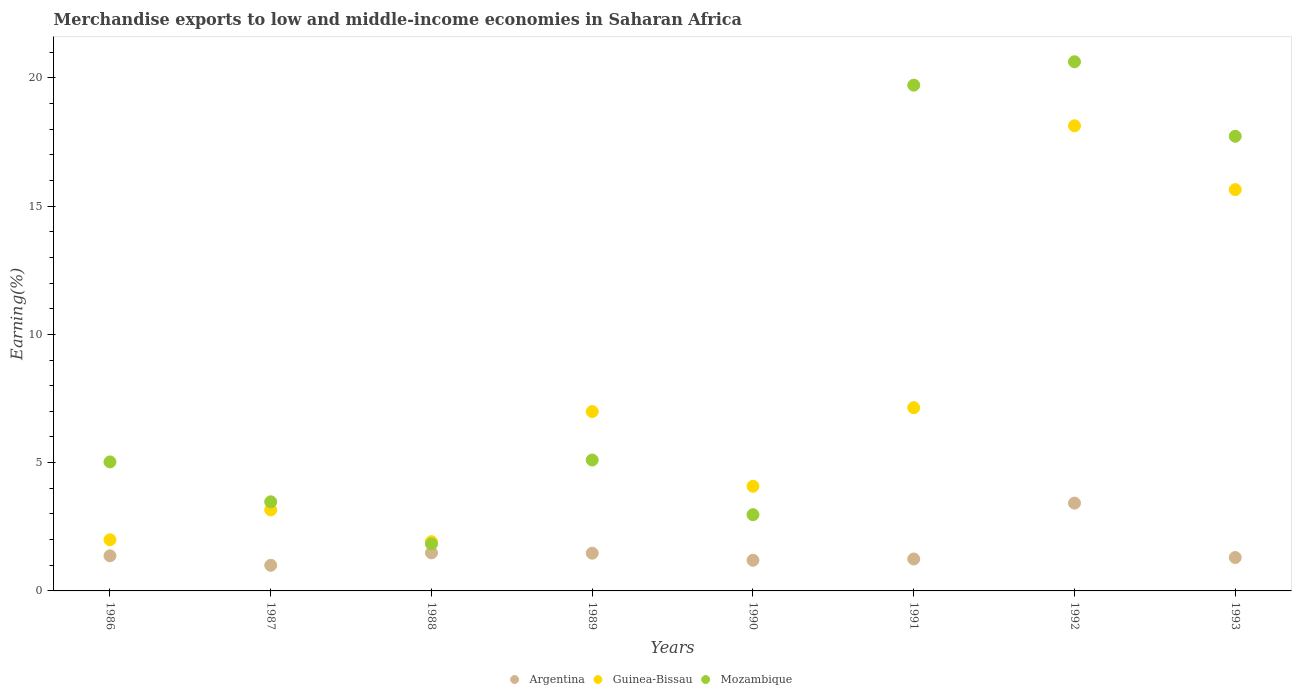What is the percentage of amount earned from merchandise exports in Mozambique in 1986?
Your answer should be very brief. 5.03. Across all years, what is the maximum percentage of amount earned from merchandise exports in Guinea-Bissau?
Offer a terse response. 18.13. Across all years, what is the minimum percentage of amount earned from merchandise exports in Argentina?
Keep it short and to the point. 1. In which year was the percentage of amount earned from merchandise exports in Guinea-Bissau minimum?
Make the answer very short. 1988. What is the total percentage of amount earned from merchandise exports in Guinea-Bissau in the graph?
Give a very brief answer. 59.05. What is the difference between the percentage of amount earned from merchandise exports in Mozambique in 1987 and that in 1992?
Your answer should be compact. -17.15. What is the difference between the percentage of amount earned from merchandise exports in Mozambique in 1993 and the percentage of amount earned from merchandise exports in Argentina in 1988?
Your answer should be compact. 16.24. What is the average percentage of amount earned from merchandise exports in Mozambique per year?
Give a very brief answer. 9.56. In the year 1992, what is the difference between the percentage of amount earned from merchandise exports in Mozambique and percentage of amount earned from merchandise exports in Argentina?
Your answer should be compact. 17.2. In how many years, is the percentage of amount earned from merchandise exports in Argentina greater than 7 %?
Your response must be concise. 0. What is the ratio of the percentage of amount earned from merchandise exports in Guinea-Bissau in 1986 to that in 1988?
Make the answer very short. 1.04. Is the difference between the percentage of amount earned from merchandise exports in Mozambique in 1990 and 1992 greater than the difference between the percentage of amount earned from merchandise exports in Argentina in 1990 and 1992?
Offer a terse response. No. What is the difference between the highest and the second highest percentage of amount earned from merchandise exports in Argentina?
Make the answer very short. 1.94. What is the difference between the highest and the lowest percentage of amount earned from merchandise exports in Guinea-Bissau?
Provide a succinct answer. 16.21. In how many years, is the percentage of amount earned from merchandise exports in Mozambique greater than the average percentage of amount earned from merchandise exports in Mozambique taken over all years?
Your answer should be very brief. 3. Is the sum of the percentage of amount earned from merchandise exports in Guinea-Bissau in 1988 and 1990 greater than the maximum percentage of amount earned from merchandise exports in Argentina across all years?
Keep it short and to the point. Yes. Is the percentage of amount earned from merchandise exports in Argentina strictly greater than the percentage of amount earned from merchandise exports in Mozambique over the years?
Keep it short and to the point. No. What is the difference between two consecutive major ticks on the Y-axis?
Your answer should be compact. 5. Are the values on the major ticks of Y-axis written in scientific E-notation?
Keep it short and to the point. No. Does the graph contain any zero values?
Keep it short and to the point. No. Does the graph contain grids?
Provide a succinct answer. No. How many legend labels are there?
Offer a very short reply. 3. How are the legend labels stacked?
Your answer should be compact. Horizontal. What is the title of the graph?
Ensure brevity in your answer.  Merchandise exports to low and middle-income economies in Saharan Africa. Does "Qatar" appear as one of the legend labels in the graph?
Give a very brief answer. No. What is the label or title of the X-axis?
Provide a short and direct response. Years. What is the label or title of the Y-axis?
Give a very brief answer. Earning(%). What is the Earning(%) in Argentina in 1986?
Offer a very short reply. 1.37. What is the Earning(%) in Guinea-Bissau in 1986?
Offer a very short reply. 1.99. What is the Earning(%) of Mozambique in 1986?
Your response must be concise. 5.03. What is the Earning(%) of Argentina in 1987?
Provide a succinct answer. 1. What is the Earning(%) of Guinea-Bissau in 1987?
Make the answer very short. 3.16. What is the Earning(%) in Mozambique in 1987?
Your answer should be very brief. 3.47. What is the Earning(%) of Argentina in 1988?
Ensure brevity in your answer.  1.48. What is the Earning(%) of Guinea-Bissau in 1988?
Your answer should be very brief. 1.92. What is the Earning(%) of Mozambique in 1988?
Your answer should be very brief. 1.83. What is the Earning(%) in Argentina in 1989?
Keep it short and to the point. 1.47. What is the Earning(%) in Guinea-Bissau in 1989?
Offer a very short reply. 6.99. What is the Earning(%) of Mozambique in 1989?
Keep it short and to the point. 5.1. What is the Earning(%) in Argentina in 1990?
Give a very brief answer. 1.19. What is the Earning(%) in Guinea-Bissau in 1990?
Keep it short and to the point. 4.08. What is the Earning(%) in Mozambique in 1990?
Provide a short and direct response. 2.97. What is the Earning(%) of Argentina in 1991?
Provide a succinct answer. 1.24. What is the Earning(%) of Guinea-Bissau in 1991?
Provide a succinct answer. 7.14. What is the Earning(%) of Mozambique in 1991?
Make the answer very short. 19.71. What is the Earning(%) in Argentina in 1992?
Your response must be concise. 3.42. What is the Earning(%) in Guinea-Bissau in 1992?
Provide a short and direct response. 18.13. What is the Earning(%) in Mozambique in 1992?
Give a very brief answer. 20.63. What is the Earning(%) in Argentina in 1993?
Your response must be concise. 1.3. What is the Earning(%) of Guinea-Bissau in 1993?
Ensure brevity in your answer.  15.64. What is the Earning(%) of Mozambique in 1993?
Keep it short and to the point. 17.72. Across all years, what is the maximum Earning(%) of Argentina?
Your answer should be compact. 3.42. Across all years, what is the maximum Earning(%) of Guinea-Bissau?
Your answer should be very brief. 18.13. Across all years, what is the maximum Earning(%) of Mozambique?
Offer a terse response. 20.63. Across all years, what is the minimum Earning(%) in Argentina?
Offer a very short reply. 1. Across all years, what is the minimum Earning(%) in Guinea-Bissau?
Make the answer very short. 1.92. Across all years, what is the minimum Earning(%) in Mozambique?
Make the answer very short. 1.83. What is the total Earning(%) of Argentina in the graph?
Provide a short and direct response. 12.49. What is the total Earning(%) of Guinea-Bissau in the graph?
Offer a terse response. 59.05. What is the total Earning(%) of Mozambique in the graph?
Keep it short and to the point. 76.47. What is the difference between the Earning(%) of Argentina in 1986 and that in 1987?
Offer a very short reply. 0.37. What is the difference between the Earning(%) in Guinea-Bissau in 1986 and that in 1987?
Ensure brevity in your answer.  -1.16. What is the difference between the Earning(%) of Mozambique in 1986 and that in 1987?
Give a very brief answer. 1.55. What is the difference between the Earning(%) in Argentina in 1986 and that in 1988?
Your response must be concise. -0.11. What is the difference between the Earning(%) in Guinea-Bissau in 1986 and that in 1988?
Your answer should be very brief. 0.07. What is the difference between the Earning(%) of Mozambique in 1986 and that in 1988?
Your answer should be very brief. 3.2. What is the difference between the Earning(%) in Argentina in 1986 and that in 1989?
Make the answer very short. -0.1. What is the difference between the Earning(%) in Guinea-Bissau in 1986 and that in 1989?
Give a very brief answer. -5. What is the difference between the Earning(%) of Mozambique in 1986 and that in 1989?
Ensure brevity in your answer.  -0.07. What is the difference between the Earning(%) in Argentina in 1986 and that in 1990?
Provide a succinct answer. 0.17. What is the difference between the Earning(%) of Guinea-Bissau in 1986 and that in 1990?
Provide a succinct answer. -2.09. What is the difference between the Earning(%) in Mozambique in 1986 and that in 1990?
Make the answer very short. 2.06. What is the difference between the Earning(%) of Argentina in 1986 and that in 1991?
Give a very brief answer. 0.12. What is the difference between the Earning(%) of Guinea-Bissau in 1986 and that in 1991?
Provide a short and direct response. -5.15. What is the difference between the Earning(%) of Mozambique in 1986 and that in 1991?
Provide a short and direct response. -14.69. What is the difference between the Earning(%) in Argentina in 1986 and that in 1992?
Provide a succinct answer. -2.05. What is the difference between the Earning(%) of Guinea-Bissau in 1986 and that in 1992?
Your response must be concise. -16.14. What is the difference between the Earning(%) in Mozambique in 1986 and that in 1992?
Make the answer very short. -15.6. What is the difference between the Earning(%) in Argentina in 1986 and that in 1993?
Provide a short and direct response. 0.07. What is the difference between the Earning(%) of Guinea-Bissau in 1986 and that in 1993?
Give a very brief answer. -13.65. What is the difference between the Earning(%) in Mozambique in 1986 and that in 1993?
Provide a short and direct response. -12.69. What is the difference between the Earning(%) of Argentina in 1987 and that in 1988?
Give a very brief answer. -0.48. What is the difference between the Earning(%) of Guinea-Bissau in 1987 and that in 1988?
Offer a terse response. 1.24. What is the difference between the Earning(%) in Mozambique in 1987 and that in 1988?
Your response must be concise. 1.64. What is the difference between the Earning(%) of Argentina in 1987 and that in 1989?
Ensure brevity in your answer.  -0.47. What is the difference between the Earning(%) in Guinea-Bissau in 1987 and that in 1989?
Ensure brevity in your answer.  -3.83. What is the difference between the Earning(%) of Mozambique in 1987 and that in 1989?
Ensure brevity in your answer.  -1.63. What is the difference between the Earning(%) in Argentina in 1987 and that in 1990?
Your answer should be very brief. -0.2. What is the difference between the Earning(%) in Guinea-Bissau in 1987 and that in 1990?
Offer a very short reply. -0.92. What is the difference between the Earning(%) in Mozambique in 1987 and that in 1990?
Your response must be concise. 0.5. What is the difference between the Earning(%) in Argentina in 1987 and that in 1991?
Provide a succinct answer. -0.25. What is the difference between the Earning(%) in Guinea-Bissau in 1987 and that in 1991?
Offer a terse response. -3.99. What is the difference between the Earning(%) of Mozambique in 1987 and that in 1991?
Your answer should be compact. -16.24. What is the difference between the Earning(%) of Argentina in 1987 and that in 1992?
Give a very brief answer. -2.42. What is the difference between the Earning(%) in Guinea-Bissau in 1987 and that in 1992?
Ensure brevity in your answer.  -14.97. What is the difference between the Earning(%) of Mozambique in 1987 and that in 1992?
Offer a terse response. -17.15. What is the difference between the Earning(%) in Argentina in 1987 and that in 1993?
Provide a succinct answer. -0.3. What is the difference between the Earning(%) in Guinea-Bissau in 1987 and that in 1993?
Offer a very short reply. -12.48. What is the difference between the Earning(%) in Mozambique in 1987 and that in 1993?
Make the answer very short. -14.25. What is the difference between the Earning(%) in Argentina in 1988 and that in 1989?
Provide a short and direct response. 0.01. What is the difference between the Earning(%) of Guinea-Bissau in 1988 and that in 1989?
Keep it short and to the point. -5.07. What is the difference between the Earning(%) in Mozambique in 1988 and that in 1989?
Provide a short and direct response. -3.27. What is the difference between the Earning(%) in Argentina in 1988 and that in 1990?
Keep it short and to the point. 0.29. What is the difference between the Earning(%) in Guinea-Bissau in 1988 and that in 1990?
Your answer should be very brief. -2.16. What is the difference between the Earning(%) in Mozambique in 1988 and that in 1990?
Make the answer very short. -1.14. What is the difference between the Earning(%) of Argentina in 1988 and that in 1991?
Keep it short and to the point. 0.24. What is the difference between the Earning(%) of Guinea-Bissau in 1988 and that in 1991?
Provide a short and direct response. -5.22. What is the difference between the Earning(%) in Mozambique in 1988 and that in 1991?
Give a very brief answer. -17.88. What is the difference between the Earning(%) of Argentina in 1988 and that in 1992?
Offer a very short reply. -1.94. What is the difference between the Earning(%) in Guinea-Bissau in 1988 and that in 1992?
Provide a short and direct response. -16.21. What is the difference between the Earning(%) of Mozambique in 1988 and that in 1992?
Give a very brief answer. -18.79. What is the difference between the Earning(%) of Argentina in 1988 and that in 1993?
Give a very brief answer. 0.18. What is the difference between the Earning(%) of Guinea-Bissau in 1988 and that in 1993?
Keep it short and to the point. -13.72. What is the difference between the Earning(%) in Mozambique in 1988 and that in 1993?
Your response must be concise. -15.89. What is the difference between the Earning(%) in Argentina in 1989 and that in 1990?
Your answer should be compact. 0.28. What is the difference between the Earning(%) of Guinea-Bissau in 1989 and that in 1990?
Provide a short and direct response. 2.91. What is the difference between the Earning(%) in Mozambique in 1989 and that in 1990?
Make the answer very short. 2.13. What is the difference between the Earning(%) of Argentina in 1989 and that in 1991?
Provide a short and direct response. 0.23. What is the difference between the Earning(%) in Guinea-Bissau in 1989 and that in 1991?
Offer a terse response. -0.15. What is the difference between the Earning(%) in Mozambique in 1989 and that in 1991?
Give a very brief answer. -14.61. What is the difference between the Earning(%) in Argentina in 1989 and that in 1992?
Provide a succinct answer. -1.95. What is the difference between the Earning(%) of Guinea-Bissau in 1989 and that in 1992?
Provide a short and direct response. -11.14. What is the difference between the Earning(%) of Mozambique in 1989 and that in 1992?
Ensure brevity in your answer.  -15.52. What is the difference between the Earning(%) in Argentina in 1989 and that in 1993?
Your answer should be compact. 0.17. What is the difference between the Earning(%) in Guinea-Bissau in 1989 and that in 1993?
Provide a short and direct response. -8.65. What is the difference between the Earning(%) in Mozambique in 1989 and that in 1993?
Provide a short and direct response. -12.62. What is the difference between the Earning(%) of Argentina in 1990 and that in 1991?
Your response must be concise. -0.05. What is the difference between the Earning(%) in Guinea-Bissau in 1990 and that in 1991?
Make the answer very short. -3.06. What is the difference between the Earning(%) of Mozambique in 1990 and that in 1991?
Your answer should be compact. -16.74. What is the difference between the Earning(%) of Argentina in 1990 and that in 1992?
Provide a succinct answer. -2.23. What is the difference between the Earning(%) of Guinea-Bissau in 1990 and that in 1992?
Offer a terse response. -14.05. What is the difference between the Earning(%) of Mozambique in 1990 and that in 1992?
Your answer should be very brief. -17.65. What is the difference between the Earning(%) of Argentina in 1990 and that in 1993?
Give a very brief answer. -0.11. What is the difference between the Earning(%) in Guinea-Bissau in 1990 and that in 1993?
Your answer should be compact. -11.56. What is the difference between the Earning(%) in Mozambique in 1990 and that in 1993?
Provide a short and direct response. -14.75. What is the difference between the Earning(%) in Argentina in 1991 and that in 1992?
Keep it short and to the point. -2.18. What is the difference between the Earning(%) of Guinea-Bissau in 1991 and that in 1992?
Give a very brief answer. -10.99. What is the difference between the Earning(%) in Mozambique in 1991 and that in 1992?
Make the answer very short. -0.91. What is the difference between the Earning(%) of Argentina in 1991 and that in 1993?
Offer a very short reply. -0.06. What is the difference between the Earning(%) of Guinea-Bissau in 1991 and that in 1993?
Provide a succinct answer. -8.5. What is the difference between the Earning(%) in Mozambique in 1991 and that in 1993?
Make the answer very short. 1.99. What is the difference between the Earning(%) in Argentina in 1992 and that in 1993?
Offer a very short reply. 2.12. What is the difference between the Earning(%) in Guinea-Bissau in 1992 and that in 1993?
Your answer should be very brief. 2.49. What is the difference between the Earning(%) of Mozambique in 1992 and that in 1993?
Offer a terse response. 2.9. What is the difference between the Earning(%) in Argentina in 1986 and the Earning(%) in Guinea-Bissau in 1987?
Offer a terse response. -1.79. What is the difference between the Earning(%) of Argentina in 1986 and the Earning(%) of Mozambique in 1987?
Offer a terse response. -2.1. What is the difference between the Earning(%) of Guinea-Bissau in 1986 and the Earning(%) of Mozambique in 1987?
Provide a short and direct response. -1.48. What is the difference between the Earning(%) in Argentina in 1986 and the Earning(%) in Guinea-Bissau in 1988?
Keep it short and to the point. -0.55. What is the difference between the Earning(%) of Argentina in 1986 and the Earning(%) of Mozambique in 1988?
Your answer should be very brief. -0.46. What is the difference between the Earning(%) in Guinea-Bissau in 1986 and the Earning(%) in Mozambique in 1988?
Offer a terse response. 0.16. What is the difference between the Earning(%) in Argentina in 1986 and the Earning(%) in Guinea-Bissau in 1989?
Give a very brief answer. -5.62. What is the difference between the Earning(%) in Argentina in 1986 and the Earning(%) in Mozambique in 1989?
Your answer should be very brief. -3.73. What is the difference between the Earning(%) in Guinea-Bissau in 1986 and the Earning(%) in Mozambique in 1989?
Ensure brevity in your answer.  -3.11. What is the difference between the Earning(%) of Argentina in 1986 and the Earning(%) of Guinea-Bissau in 1990?
Offer a very short reply. -2.71. What is the difference between the Earning(%) of Argentina in 1986 and the Earning(%) of Mozambique in 1990?
Provide a succinct answer. -1.6. What is the difference between the Earning(%) of Guinea-Bissau in 1986 and the Earning(%) of Mozambique in 1990?
Offer a very short reply. -0.98. What is the difference between the Earning(%) in Argentina in 1986 and the Earning(%) in Guinea-Bissau in 1991?
Ensure brevity in your answer.  -5.77. What is the difference between the Earning(%) in Argentina in 1986 and the Earning(%) in Mozambique in 1991?
Offer a terse response. -18.34. What is the difference between the Earning(%) of Guinea-Bissau in 1986 and the Earning(%) of Mozambique in 1991?
Ensure brevity in your answer.  -17.72. What is the difference between the Earning(%) in Argentina in 1986 and the Earning(%) in Guinea-Bissau in 1992?
Provide a short and direct response. -16.76. What is the difference between the Earning(%) of Argentina in 1986 and the Earning(%) of Mozambique in 1992?
Provide a short and direct response. -19.26. What is the difference between the Earning(%) of Guinea-Bissau in 1986 and the Earning(%) of Mozambique in 1992?
Keep it short and to the point. -18.63. What is the difference between the Earning(%) of Argentina in 1986 and the Earning(%) of Guinea-Bissau in 1993?
Your answer should be very brief. -14.27. What is the difference between the Earning(%) of Argentina in 1986 and the Earning(%) of Mozambique in 1993?
Provide a succinct answer. -16.35. What is the difference between the Earning(%) of Guinea-Bissau in 1986 and the Earning(%) of Mozambique in 1993?
Your response must be concise. -15.73. What is the difference between the Earning(%) of Argentina in 1987 and the Earning(%) of Guinea-Bissau in 1988?
Provide a short and direct response. -0.92. What is the difference between the Earning(%) in Argentina in 1987 and the Earning(%) in Mozambique in 1988?
Your answer should be compact. -0.83. What is the difference between the Earning(%) in Guinea-Bissau in 1987 and the Earning(%) in Mozambique in 1988?
Make the answer very short. 1.33. What is the difference between the Earning(%) of Argentina in 1987 and the Earning(%) of Guinea-Bissau in 1989?
Provide a succinct answer. -5.99. What is the difference between the Earning(%) of Argentina in 1987 and the Earning(%) of Mozambique in 1989?
Provide a succinct answer. -4.1. What is the difference between the Earning(%) in Guinea-Bissau in 1987 and the Earning(%) in Mozambique in 1989?
Make the answer very short. -1.94. What is the difference between the Earning(%) in Argentina in 1987 and the Earning(%) in Guinea-Bissau in 1990?
Provide a succinct answer. -3.08. What is the difference between the Earning(%) in Argentina in 1987 and the Earning(%) in Mozambique in 1990?
Make the answer very short. -1.97. What is the difference between the Earning(%) of Guinea-Bissau in 1987 and the Earning(%) of Mozambique in 1990?
Provide a short and direct response. 0.19. What is the difference between the Earning(%) of Argentina in 1987 and the Earning(%) of Guinea-Bissau in 1991?
Your answer should be very brief. -6.14. What is the difference between the Earning(%) of Argentina in 1987 and the Earning(%) of Mozambique in 1991?
Give a very brief answer. -18.71. What is the difference between the Earning(%) of Guinea-Bissau in 1987 and the Earning(%) of Mozambique in 1991?
Make the answer very short. -16.56. What is the difference between the Earning(%) in Argentina in 1987 and the Earning(%) in Guinea-Bissau in 1992?
Make the answer very short. -17.13. What is the difference between the Earning(%) of Argentina in 1987 and the Earning(%) of Mozambique in 1992?
Your response must be concise. -19.63. What is the difference between the Earning(%) in Guinea-Bissau in 1987 and the Earning(%) in Mozambique in 1992?
Provide a short and direct response. -17.47. What is the difference between the Earning(%) in Argentina in 1987 and the Earning(%) in Guinea-Bissau in 1993?
Your answer should be very brief. -14.64. What is the difference between the Earning(%) of Argentina in 1987 and the Earning(%) of Mozambique in 1993?
Your answer should be very brief. -16.72. What is the difference between the Earning(%) in Guinea-Bissau in 1987 and the Earning(%) in Mozambique in 1993?
Make the answer very short. -14.56. What is the difference between the Earning(%) of Argentina in 1988 and the Earning(%) of Guinea-Bissau in 1989?
Provide a succinct answer. -5.51. What is the difference between the Earning(%) in Argentina in 1988 and the Earning(%) in Mozambique in 1989?
Keep it short and to the point. -3.62. What is the difference between the Earning(%) in Guinea-Bissau in 1988 and the Earning(%) in Mozambique in 1989?
Offer a very short reply. -3.18. What is the difference between the Earning(%) of Argentina in 1988 and the Earning(%) of Guinea-Bissau in 1990?
Keep it short and to the point. -2.6. What is the difference between the Earning(%) of Argentina in 1988 and the Earning(%) of Mozambique in 1990?
Give a very brief answer. -1.49. What is the difference between the Earning(%) in Guinea-Bissau in 1988 and the Earning(%) in Mozambique in 1990?
Offer a very short reply. -1.05. What is the difference between the Earning(%) of Argentina in 1988 and the Earning(%) of Guinea-Bissau in 1991?
Keep it short and to the point. -5.66. What is the difference between the Earning(%) of Argentina in 1988 and the Earning(%) of Mozambique in 1991?
Your answer should be compact. -18.23. What is the difference between the Earning(%) in Guinea-Bissau in 1988 and the Earning(%) in Mozambique in 1991?
Give a very brief answer. -17.79. What is the difference between the Earning(%) of Argentina in 1988 and the Earning(%) of Guinea-Bissau in 1992?
Give a very brief answer. -16.65. What is the difference between the Earning(%) of Argentina in 1988 and the Earning(%) of Mozambique in 1992?
Make the answer very short. -19.14. What is the difference between the Earning(%) of Guinea-Bissau in 1988 and the Earning(%) of Mozambique in 1992?
Ensure brevity in your answer.  -18.71. What is the difference between the Earning(%) of Argentina in 1988 and the Earning(%) of Guinea-Bissau in 1993?
Provide a short and direct response. -14.16. What is the difference between the Earning(%) of Argentina in 1988 and the Earning(%) of Mozambique in 1993?
Ensure brevity in your answer.  -16.24. What is the difference between the Earning(%) in Guinea-Bissau in 1988 and the Earning(%) in Mozambique in 1993?
Offer a terse response. -15.8. What is the difference between the Earning(%) in Argentina in 1989 and the Earning(%) in Guinea-Bissau in 1990?
Make the answer very short. -2.61. What is the difference between the Earning(%) of Argentina in 1989 and the Earning(%) of Mozambique in 1990?
Your answer should be very brief. -1.5. What is the difference between the Earning(%) in Guinea-Bissau in 1989 and the Earning(%) in Mozambique in 1990?
Offer a very short reply. 4.02. What is the difference between the Earning(%) in Argentina in 1989 and the Earning(%) in Guinea-Bissau in 1991?
Offer a very short reply. -5.67. What is the difference between the Earning(%) in Argentina in 1989 and the Earning(%) in Mozambique in 1991?
Keep it short and to the point. -18.24. What is the difference between the Earning(%) in Guinea-Bissau in 1989 and the Earning(%) in Mozambique in 1991?
Give a very brief answer. -12.72. What is the difference between the Earning(%) in Argentina in 1989 and the Earning(%) in Guinea-Bissau in 1992?
Your answer should be very brief. -16.66. What is the difference between the Earning(%) of Argentina in 1989 and the Earning(%) of Mozambique in 1992?
Offer a terse response. -19.16. What is the difference between the Earning(%) of Guinea-Bissau in 1989 and the Earning(%) of Mozambique in 1992?
Offer a terse response. -13.63. What is the difference between the Earning(%) of Argentina in 1989 and the Earning(%) of Guinea-Bissau in 1993?
Your answer should be compact. -14.17. What is the difference between the Earning(%) of Argentina in 1989 and the Earning(%) of Mozambique in 1993?
Your response must be concise. -16.25. What is the difference between the Earning(%) of Guinea-Bissau in 1989 and the Earning(%) of Mozambique in 1993?
Your answer should be very brief. -10.73. What is the difference between the Earning(%) in Argentina in 1990 and the Earning(%) in Guinea-Bissau in 1991?
Make the answer very short. -5.95. What is the difference between the Earning(%) of Argentina in 1990 and the Earning(%) of Mozambique in 1991?
Offer a terse response. -18.52. What is the difference between the Earning(%) in Guinea-Bissau in 1990 and the Earning(%) in Mozambique in 1991?
Give a very brief answer. -15.63. What is the difference between the Earning(%) of Argentina in 1990 and the Earning(%) of Guinea-Bissau in 1992?
Your response must be concise. -16.93. What is the difference between the Earning(%) of Argentina in 1990 and the Earning(%) of Mozambique in 1992?
Provide a succinct answer. -19.43. What is the difference between the Earning(%) of Guinea-Bissau in 1990 and the Earning(%) of Mozambique in 1992?
Your response must be concise. -16.55. What is the difference between the Earning(%) in Argentina in 1990 and the Earning(%) in Guinea-Bissau in 1993?
Your answer should be compact. -14.45. What is the difference between the Earning(%) of Argentina in 1990 and the Earning(%) of Mozambique in 1993?
Give a very brief answer. -16.53. What is the difference between the Earning(%) in Guinea-Bissau in 1990 and the Earning(%) in Mozambique in 1993?
Your response must be concise. -13.64. What is the difference between the Earning(%) in Argentina in 1991 and the Earning(%) in Guinea-Bissau in 1992?
Your answer should be compact. -16.88. What is the difference between the Earning(%) in Argentina in 1991 and the Earning(%) in Mozambique in 1992?
Provide a succinct answer. -19.38. What is the difference between the Earning(%) of Guinea-Bissau in 1991 and the Earning(%) of Mozambique in 1992?
Offer a very short reply. -13.48. What is the difference between the Earning(%) of Argentina in 1991 and the Earning(%) of Guinea-Bissau in 1993?
Provide a succinct answer. -14.4. What is the difference between the Earning(%) in Argentina in 1991 and the Earning(%) in Mozambique in 1993?
Offer a very short reply. -16.48. What is the difference between the Earning(%) in Guinea-Bissau in 1991 and the Earning(%) in Mozambique in 1993?
Provide a short and direct response. -10.58. What is the difference between the Earning(%) in Argentina in 1992 and the Earning(%) in Guinea-Bissau in 1993?
Your answer should be very brief. -12.22. What is the difference between the Earning(%) in Argentina in 1992 and the Earning(%) in Mozambique in 1993?
Offer a very short reply. -14.3. What is the difference between the Earning(%) in Guinea-Bissau in 1992 and the Earning(%) in Mozambique in 1993?
Provide a succinct answer. 0.41. What is the average Earning(%) in Argentina per year?
Your answer should be compact. 1.56. What is the average Earning(%) of Guinea-Bissau per year?
Offer a terse response. 7.38. What is the average Earning(%) of Mozambique per year?
Your response must be concise. 9.56. In the year 1986, what is the difference between the Earning(%) in Argentina and Earning(%) in Guinea-Bissau?
Keep it short and to the point. -0.62. In the year 1986, what is the difference between the Earning(%) of Argentina and Earning(%) of Mozambique?
Offer a very short reply. -3.66. In the year 1986, what is the difference between the Earning(%) of Guinea-Bissau and Earning(%) of Mozambique?
Give a very brief answer. -3.04. In the year 1987, what is the difference between the Earning(%) of Argentina and Earning(%) of Guinea-Bissau?
Your answer should be compact. -2.16. In the year 1987, what is the difference between the Earning(%) in Argentina and Earning(%) in Mozambique?
Ensure brevity in your answer.  -2.47. In the year 1987, what is the difference between the Earning(%) of Guinea-Bissau and Earning(%) of Mozambique?
Offer a terse response. -0.32. In the year 1988, what is the difference between the Earning(%) of Argentina and Earning(%) of Guinea-Bissau?
Your response must be concise. -0.44. In the year 1988, what is the difference between the Earning(%) in Argentina and Earning(%) in Mozambique?
Your answer should be compact. -0.35. In the year 1988, what is the difference between the Earning(%) in Guinea-Bissau and Earning(%) in Mozambique?
Provide a succinct answer. 0.09. In the year 1989, what is the difference between the Earning(%) in Argentina and Earning(%) in Guinea-Bissau?
Ensure brevity in your answer.  -5.52. In the year 1989, what is the difference between the Earning(%) in Argentina and Earning(%) in Mozambique?
Give a very brief answer. -3.63. In the year 1989, what is the difference between the Earning(%) of Guinea-Bissau and Earning(%) of Mozambique?
Make the answer very short. 1.89. In the year 1990, what is the difference between the Earning(%) in Argentina and Earning(%) in Guinea-Bissau?
Provide a succinct answer. -2.88. In the year 1990, what is the difference between the Earning(%) of Argentina and Earning(%) of Mozambique?
Your response must be concise. -1.78. In the year 1990, what is the difference between the Earning(%) in Guinea-Bissau and Earning(%) in Mozambique?
Ensure brevity in your answer.  1.11. In the year 1991, what is the difference between the Earning(%) of Argentina and Earning(%) of Guinea-Bissau?
Offer a very short reply. -5.9. In the year 1991, what is the difference between the Earning(%) of Argentina and Earning(%) of Mozambique?
Provide a short and direct response. -18.47. In the year 1991, what is the difference between the Earning(%) in Guinea-Bissau and Earning(%) in Mozambique?
Keep it short and to the point. -12.57. In the year 1992, what is the difference between the Earning(%) of Argentina and Earning(%) of Guinea-Bissau?
Your answer should be very brief. -14.71. In the year 1992, what is the difference between the Earning(%) of Argentina and Earning(%) of Mozambique?
Offer a very short reply. -17.2. In the year 1992, what is the difference between the Earning(%) of Guinea-Bissau and Earning(%) of Mozambique?
Make the answer very short. -2.5. In the year 1993, what is the difference between the Earning(%) in Argentina and Earning(%) in Guinea-Bissau?
Your answer should be compact. -14.34. In the year 1993, what is the difference between the Earning(%) in Argentina and Earning(%) in Mozambique?
Your answer should be compact. -16.42. In the year 1993, what is the difference between the Earning(%) in Guinea-Bissau and Earning(%) in Mozambique?
Ensure brevity in your answer.  -2.08. What is the ratio of the Earning(%) in Argentina in 1986 to that in 1987?
Provide a short and direct response. 1.37. What is the ratio of the Earning(%) of Guinea-Bissau in 1986 to that in 1987?
Ensure brevity in your answer.  0.63. What is the ratio of the Earning(%) of Mozambique in 1986 to that in 1987?
Your response must be concise. 1.45. What is the ratio of the Earning(%) in Argentina in 1986 to that in 1988?
Make the answer very short. 0.92. What is the ratio of the Earning(%) of Guinea-Bissau in 1986 to that in 1988?
Provide a succinct answer. 1.04. What is the ratio of the Earning(%) of Mozambique in 1986 to that in 1988?
Your answer should be very brief. 2.75. What is the ratio of the Earning(%) in Argentina in 1986 to that in 1989?
Offer a very short reply. 0.93. What is the ratio of the Earning(%) of Guinea-Bissau in 1986 to that in 1989?
Your answer should be very brief. 0.29. What is the ratio of the Earning(%) of Mozambique in 1986 to that in 1989?
Your answer should be very brief. 0.99. What is the ratio of the Earning(%) in Argentina in 1986 to that in 1990?
Ensure brevity in your answer.  1.15. What is the ratio of the Earning(%) of Guinea-Bissau in 1986 to that in 1990?
Offer a very short reply. 0.49. What is the ratio of the Earning(%) in Mozambique in 1986 to that in 1990?
Provide a succinct answer. 1.69. What is the ratio of the Earning(%) in Argentina in 1986 to that in 1991?
Provide a short and direct response. 1.1. What is the ratio of the Earning(%) in Guinea-Bissau in 1986 to that in 1991?
Provide a succinct answer. 0.28. What is the ratio of the Earning(%) in Mozambique in 1986 to that in 1991?
Offer a terse response. 0.26. What is the ratio of the Earning(%) of Argentina in 1986 to that in 1992?
Provide a short and direct response. 0.4. What is the ratio of the Earning(%) of Guinea-Bissau in 1986 to that in 1992?
Your answer should be very brief. 0.11. What is the ratio of the Earning(%) in Mozambique in 1986 to that in 1992?
Provide a succinct answer. 0.24. What is the ratio of the Earning(%) of Argentina in 1986 to that in 1993?
Offer a very short reply. 1.05. What is the ratio of the Earning(%) of Guinea-Bissau in 1986 to that in 1993?
Provide a succinct answer. 0.13. What is the ratio of the Earning(%) in Mozambique in 1986 to that in 1993?
Your response must be concise. 0.28. What is the ratio of the Earning(%) of Argentina in 1987 to that in 1988?
Offer a very short reply. 0.67. What is the ratio of the Earning(%) in Guinea-Bissau in 1987 to that in 1988?
Provide a short and direct response. 1.64. What is the ratio of the Earning(%) of Mozambique in 1987 to that in 1988?
Offer a terse response. 1.9. What is the ratio of the Earning(%) in Argentina in 1987 to that in 1989?
Provide a short and direct response. 0.68. What is the ratio of the Earning(%) in Guinea-Bissau in 1987 to that in 1989?
Provide a succinct answer. 0.45. What is the ratio of the Earning(%) of Mozambique in 1987 to that in 1989?
Ensure brevity in your answer.  0.68. What is the ratio of the Earning(%) in Argentina in 1987 to that in 1990?
Provide a short and direct response. 0.84. What is the ratio of the Earning(%) of Guinea-Bissau in 1987 to that in 1990?
Offer a terse response. 0.77. What is the ratio of the Earning(%) in Mozambique in 1987 to that in 1990?
Provide a succinct answer. 1.17. What is the ratio of the Earning(%) of Argentina in 1987 to that in 1991?
Provide a succinct answer. 0.8. What is the ratio of the Earning(%) in Guinea-Bissau in 1987 to that in 1991?
Give a very brief answer. 0.44. What is the ratio of the Earning(%) in Mozambique in 1987 to that in 1991?
Provide a short and direct response. 0.18. What is the ratio of the Earning(%) of Argentina in 1987 to that in 1992?
Provide a succinct answer. 0.29. What is the ratio of the Earning(%) in Guinea-Bissau in 1987 to that in 1992?
Provide a short and direct response. 0.17. What is the ratio of the Earning(%) of Mozambique in 1987 to that in 1992?
Provide a succinct answer. 0.17. What is the ratio of the Earning(%) of Argentina in 1987 to that in 1993?
Keep it short and to the point. 0.77. What is the ratio of the Earning(%) in Guinea-Bissau in 1987 to that in 1993?
Provide a short and direct response. 0.2. What is the ratio of the Earning(%) of Mozambique in 1987 to that in 1993?
Your response must be concise. 0.2. What is the ratio of the Earning(%) in Argentina in 1988 to that in 1989?
Ensure brevity in your answer.  1.01. What is the ratio of the Earning(%) in Guinea-Bissau in 1988 to that in 1989?
Offer a terse response. 0.27. What is the ratio of the Earning(%) of Mozambique in 1988 to that in 1989?
Keep it short and to the point. 0.36. What is the ratio of the Earning(%) of Argentina in 1988 to that in 1990?
Your answer should be very brief. 1.24. What is the ratio of the Earning(%) in Guinea-Bissau in 1988 to that in 1990?
Give a very brief answer. 0.47. What is the ratio of the Earning(%) of Mozambique in 1988 to that in 1990?
Provide a short and direct response. 0.62. What is the ratio of the Earning(%) in Argentina in 1988 to that in 1991?
Offer a very short reply. 1.19. What is the ratio of the Earning(%) in Guinea-Bissau in 1988 to that in 1991?
Make the answer very short. 0.27. What is the ratio of the Earning(%) in Mozambique in 1988 to that in 1991?
Provide a short and direct response. 0.09. What is the ratio of the Earning(%) in Argentina in 1988 to that in 1992?
Keep it short and to the point. 0.43. What is the ratio of the Earning(%) of Guinea-Bissau in 1988 to that in 1992?
Make the answer very short. 0.11. What is the ratio of the Earning(%) of Mozambique in 1988 to that in 1992?
Your answer should be very brief. 0.09. What is the ratio of the Earning(%) of Argentina in 1988 to that in 1993?
Your answer should be compact. 1.14. What is the ratio of the Earning(%) in Guinea-Bissau in 1988 to that in 1993?
Offer a very short reply. 0.12. What is the ratio of the Earning(%) of Mozambique in 1988 to that in 1993?
Keep it short and to the point. 0.1. What is the ratio of the Earning(%) of Argentina in 1989 to that in 1990?
Your answer should be very brief. 1.23. What is the ratio of the Earning(%) in Guinea-Bissau in 1989 to that in 1990?
Your answer should be compact. 1.71. What is the ratio of the Earning(%) in Mozambique in 1989 to that in 1990?
Your answer should be very brief. 1.72. What is the ratio of the Earning(%) of Argentina in 1989 to that in 1991?
Provide a succinct answer. 1.18. What is the ratio of the Earning(%) of Guinea-Bissau in 1989 to that in 1991?
Ensure brevity in your answer.  0.98. What is the ratio of the Earning(%) in Mozambique in 1989 to that in 1991?
Your answer should be very brief. 0.26. What is the ratio of the Earning(%) in Argentina in 1989 to that in 1992?
Make the answer very short. 0.43. What is the ratio of the Earning(%) of Guinea-Bissau in 1989 to that in 1992?
Keep it short and to the point. 0.39. What is the ratio of the Earning(%) in Mozambique in 1989 to that in 1992?
Provide a succinct answer. 0.25. What is the ratio of the Earning(%) in Argentina in 1989 to that in 1993?
Your response must be concise. 1.13. What is the ratio of the Earning(%) in Guinea-Bissau in 1989 to that in 1993?
Make the answer very short. 0.45. What is the ratio of the Earning(%) in Mozambique in 1989 to that in 1993?
Give a very brief answer. 0.29. What is the ratio of the Earning(%) in Guinea-Bissau in 1990 to that in 1991?
Provide a short and direct response. 0.57. What is the ratio of the Earning(%) in Mozambique in 1990 to that in 1991?
Offer a terse response. 0.15. What is the ratio of the Earning(%) of Argentina in 1990 to that in 1992?
Make the answer very short. 0.35. What is the ratio of the Earning(%) of Guinea-Bissau in 1990 to that in 1992?
Keep it short and to the point. 0.23. What is the ratio of the Earning(%) in Mozambique in 1990 to that in 1992?
Make the answer very short. 0.14. What is the ratio of the Earning(%) of Argentina in 1990 to that in 1993?
Provide a succinct answer. 0.92. What is the ratio of the Earning(%) in Guinea-Bissau in 1990 to that in 1993?
Make the answer very short. 0.26. What is the ratio of the Earning(%) in Mozambique in 1990 to that in 1993?
Your answer should be very brief. 0.17. What is the ratio of the Earning(%) of Argentina in 1991 to that in 1992?
Your answer should be very brief. 0.36. What is the ratio of the Earning(%) of Guinea-Bissau in 1991 to that in 1992?
Ensure brevity in your answer.  0.39. What is the ratio of the Earning(%) of Mozambique in 1991 to that in 1992?
Your response must be concise. 0.96. What is the ratio of the Earning(%) in Argentina in 1991 to that in 1993?
Your answer should be compact. 0.96. What is the ratio of the Earning(%) of Guinea-Bissau in 1991 to that in 1993?
Keep it short and to the point. 0.46. What is the ratio of the Earning(%) in Mozambique in 1991 to that in 1993?
Your answer should be compact. 1.11. What is the ratio of the Earning(%) of Argentina in 1992 to that in 1993?
Give a very brief answer. 2.63. What is the ratio of the Earning(%) in Guinea-Bissau in 1992 to that in 1993?
Ensure brevity in your answer.  1.16. What is the ratio of the Earning(%) of Mozambique in 1992 to that in 1993?
Provide a short and direct response. 1.16. What is the difference between the highest and the second highest Earning(%) in Argentina?
Your response must be concise. 1.94. What is the difference between the highest and the second highest Earning(%) of Guinea-Bissau?
Your answer should be compact. 2.49. What is the difference between the highest and the second highest Earning(%) of Mozambique?
Provide a succinct answer. 0.91. What is the difference between the highest and the lowest Earning(%) in Argentina?
Make the answer very short. 2.42. What is the difference between the highest and the lowest Earning(%) in Guinea-Bissau?
Give a very brief answer. 16.21. What is the difference between the highest and the lowest Earning(%) in Mozambique?
Offer a very short reply. 18.79. 